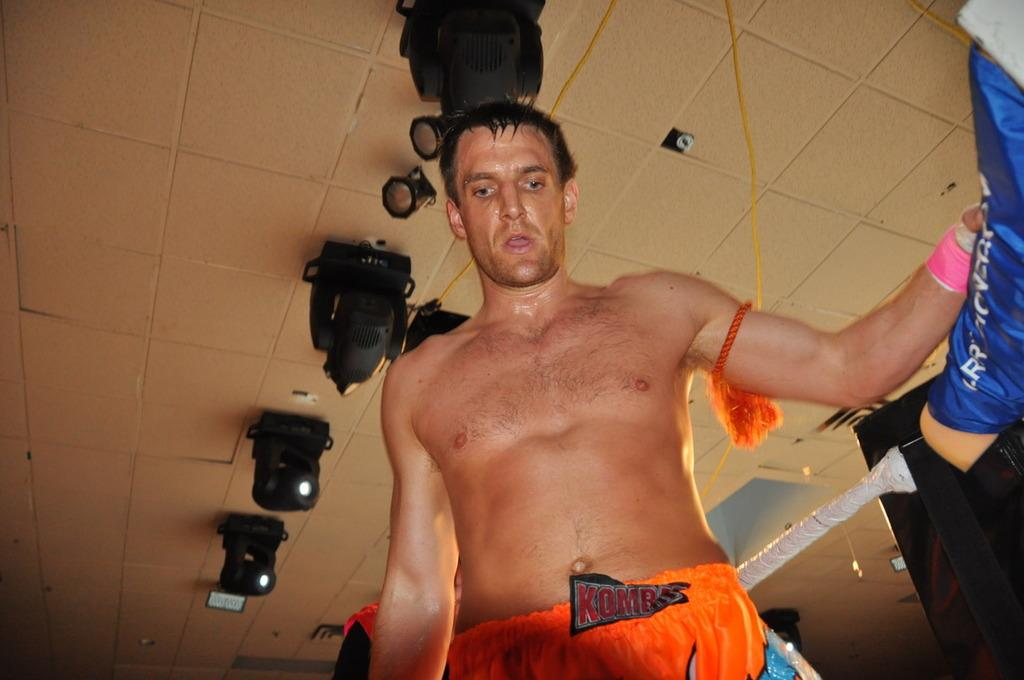What is the main subject of the image? There is a person in the image. What can be seen attached to the ceiling in the image? Focusing lights are attached to the ceiling. What is the person holding in the image? The person is holding an object. What religious beliefs does the person in the image follow? There is no information about the person's religious beliefs in the image. What flavor of the object is the person holding? The image does not provide information about the flavor of the object being held. 